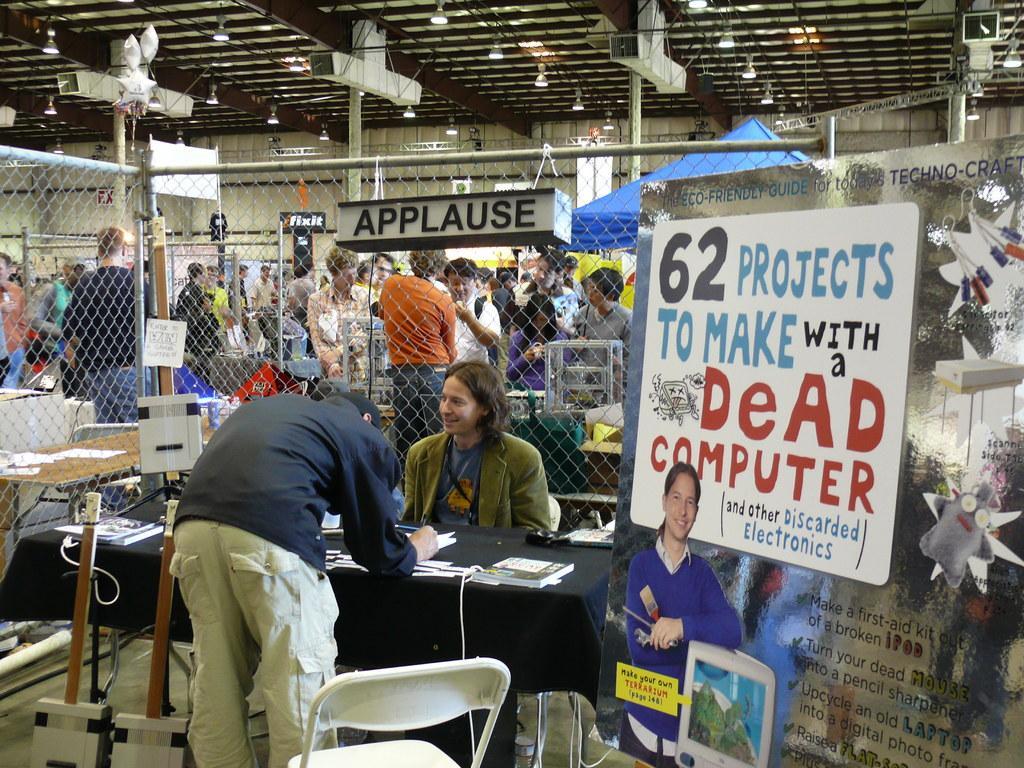Could you give a brief overview of what you see in this image? In this image In the middle there is a table on that there is a book, papers and some other items, In front of that there is a man he wear t shirt and trouser he is writing something , in front of him there is a man he is smiling. In the background there are many people. On the right there is a poster. 